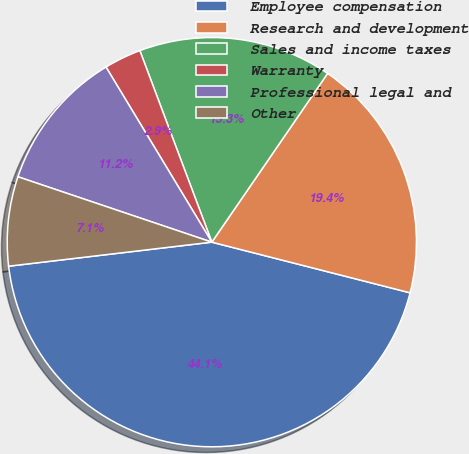Convert chart to OTSL. <chart><loc_0><loc_0><loc_500><loc_500><pie_chart><fcel>Employee compensation<fcel>Research and development<fcel>Sales and income taxes<fcel>Warranty<fcel>Professional legal and<fcel>Other<nl><fcel>44.14%<fcel>19.41%<fcel>15.29%<fcel>2.93%<fcel>11.17%<fcel>7.05%<nl></chart> 